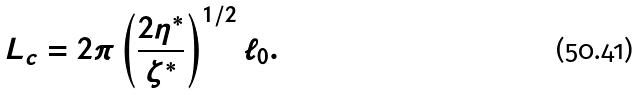<formula> <loc_0><loc_0><loc_500><loc_500>L _ { c } = 2 \pi \left ( \frac { 2 \eta ^ { * } } { \zeta ^ { * } } \right ) ^ { 1 / 2 } \ell _ { 0 } .</formula> 